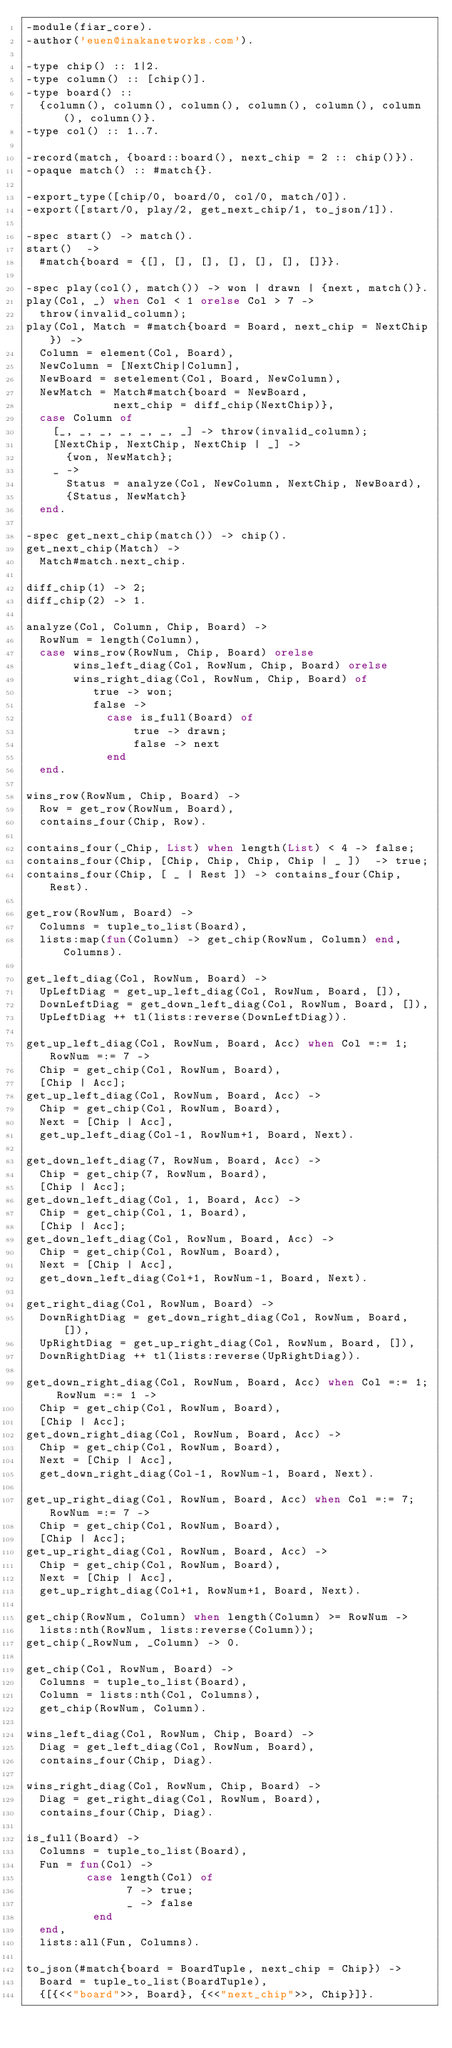<code> <loc_0><loc_0><loc_500><loc_500><_Erlang_>-module(fiar_core).
-author('euen@inakanetworks.com').

-type chip() :: 1|2.
-type column() :: [chip()].
-type board() ::
  {column(), column(), column(), column(), column(), column(), column()}.
-type col() :: 1..7.

-record(match, {board::board(), next_chip = 2 :: chip()}).
-opaque match() :: #match{}.

-export_type([chip/0, board/0, col/0, match/0]).
-export([start/0, play/2, get_next_chip/1, to_json/1]).

-spec start() -> match().
start()  -> 
  #match{board = {[], [], [], [], [], [], []}}.

-spec play(col(), match()) -> won | drawn | {next, match()}.
play(Col, _) when Col < 1 orelse Col > 7 ->
  throw(invalid_column);
play(Col, Match = #match{board = Board, next_chip = NextChip}) ->
  Column = element(Col, Board),
  NewColumn = [NextChip|Column],
  NewBoard = setelement(Col, Board, NewColumn),
  NewMatch = Match#match{board = NewBoard,
             next_chip = diff_chip(NextChip)},
  case Column of
    [_, _, _, _, _, _, _] -> throw(invalid_column);
    [NextChip, NextChip, NextChip | _] ->
      {won, NewMatch};
    _ ->
      Status = analyze(Col, NewColumn, NextChip, NewBoard),
      {Status, NewMatch}
  end.

-spec get_next_chip(match()) -> chip().
get_next_chip(Match) ->
  Match#match.next_chip.

diff_chip(1) -> 2;
diff_chip(2) -> 1.

analyze(Col, Column, Chip, Board) ->
  RowNum = length(Column),
  case wins_row(RowNum, Chip, Board) orelse
       wins_left_diag(Col, RowNum, Chip, Board) orelse
       wins_right_diag(Col, RowNum, Chip, Board) of
          true -> won;
          false ->
            case is_full(Board) of
                true -> drawn;
                false -> next
            end
  end.

wins_row(RowNum, Chip, Board) ->
  Row = get_row(RowNum, Board),
  contains_four(Chip, Row).
 
contains_four(_Chip, List) when length(List) < 4 -> false;
contains_four(Chip, [Chip, Chip, Chip, Chip | _ ])  -> true;
contains_four(Chip, [ _ | Rest ]) -> contains_four(Chip, Rest).

get_row(RowNum, Board) ->
  Columns = tuple_to_list(Board),
  lists:map(fun(Column) -> get_chip(RowNum, Column) end, Columns).

get_left_diag(Col, RowNum, Board) ->
  UpLeftDiag = get_up_left_diag(Col, RowNum, Board, []),
  DownLeftDiag = get_down_left_diag(Col, RowNum, Board, []),
  UpLeftDiag ++ tl(lists:reverse(DownLeftDiag)).

get_up_left_diag(Col, RowNum, Board, Acc) when Col =:= 1; RowNum =:= 7 ->
  Chip = get_chip(Col, RowNum, Board),
  [Chip | Acc];
get_up_left_diag(Col, RowNum, Board, Acc) ->
  Chip = get_chip(Col, RowNum, Board),
  Next = [Chip | Acc],
  get_up_left_diag(Col-1, RowNum+1, Board, Next).

get_down_left_diag(7, RowNum, Board, Acc) ->
  Chip = get_chip(7, RowNum, Board),
  [Chip | Acc];
get_down_left_diag(Col, 1, Board, Acc) -> 
  Chip = get_chip(Col, 1, Board),
  [Chip | Acc];
get_down_left_diag(Col, RowNum, Board, Acc) ->
  Chip = get_chip(Col, RowNum, Board),
  Next = [Chip | Acc],
  get_down_left_diag(Col+1, RowNum-1, Board, Next).

get_right_diag(Col, RowNum, Board) ->
  DownRightDiag = get_down_right_diag(Col, RowNum, Board, []),
  UpRightDiag = get_up_right_diag(Col, RowNum, Board, []),
  DownRightDiag ++ tl(lists:reverse(UpRightDiag)).

get_down_right_diag(Col, RowNum, Board, Acc) when Col =:= 1; RowNum =:= 1 ->
  Chip = get_chip(Col, RowNum, Board),
  [Chip | Acc];
get_down_right_diag(Col, RowNum, Board, Acc) ->
  Chip = get_chip(Col, RowNum, Board),
  Next = [Chip | Acc],
  get_down_right_diag(Col-1, RowNum-1, Board, Next).

get_up_right_diag(Col, RowNum, Board, Acc) when Col =:= 7; RowNum =:= 7 ->
  Chip = get_chip(Col, RowNum, Board),
  [Chip | Acc];
get_up_right_diag(Col, RowNum, Board, Acc) ->
  Chip = get_chip(Col, RowNum, Board),
  Next = [Chip | Acc],
  get_up_right_diag(Col+1, RowNum+1, Board, Next).

get_chip(RowNum, Column) when length(Column) >= RowNum ->
  lists:nth(RowNum, lists:reverse(Column));
get_chip(_RowNum, _Column) -> 0.

get_chip(Col, RowNum, Board) ->
  Columns = tuple_to_list(Board),
  Column = lists:nth(Col, Columns),
  get_chip(RowNum, Column).

wins_left_diag(Col, RowNum, Chip, Board) ->
  Diag = get_left_diag(Col, RowNum, Board),
  contains_four(Chip, Diag).

wins_right_diag(Col, RowNum, Chip, Board) ->
  Diag = get_right_diag(Col, RowNum, Board),
  contains_four(Chip, Diag).

is_full(Board) ->
  Columns = tuple_to_list(Board),
  Fun = fun(Col) ->
         case length(Col) of
               7 -> true;
               _ -> false
          end
  end,
  lists:all(Fun, Columns).

to_json(#match{board = BoardTuple, next_chip = Chip}) ->
  Board = tuple_to_list(BoardTuple),
  {[{<<"board">>, Board}, {<<"next_chip">>, Chip}]}. 
</code> 